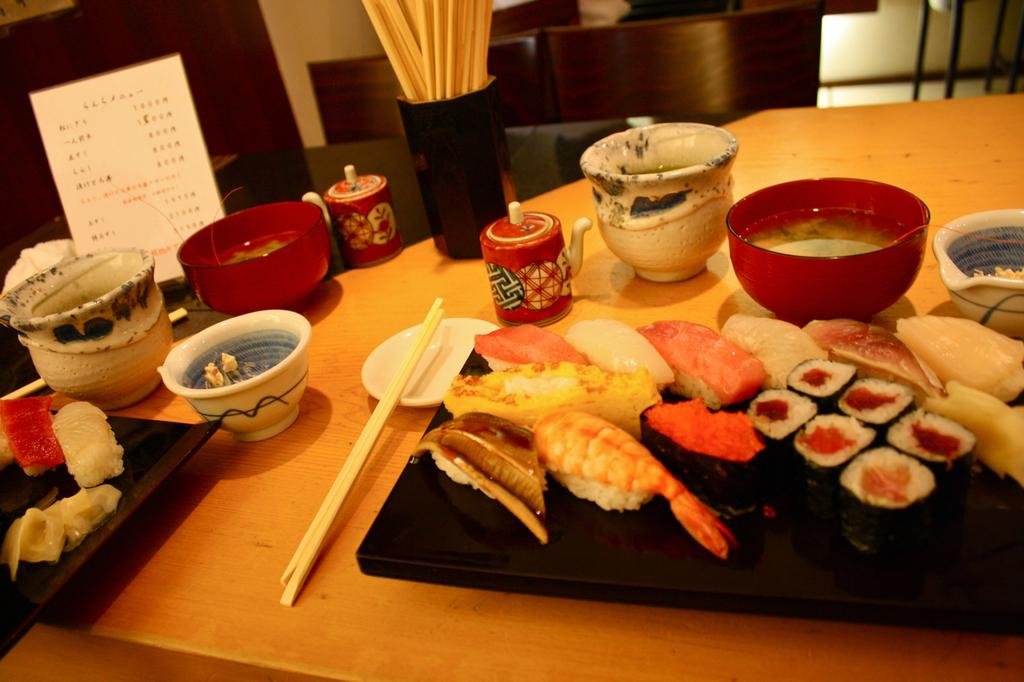What type of furniture is present in the image? There is a table in the image. What is placed on the table? There is a tray, a bowl, a teapot, and a plate on the table. What utensils are visible in the image? There are chopsticks in the image. What can be seen on the tray? There is food visible in the image. What is the purpose of the stand in the image? The stand is not explicitly described in the facts, so we cannot determine its purpose. What is written on the card in the image? The facts do not mention any text or message on the card, so we cannot determine its content. What type of seating is visible in the background of the image? There are chairs in the background of the image. What type of dirt can be seen on the table in the image? There is no dirt visible on the table in the image. What kind of yam is being served on the plate in the image? The facts do not mention any specific type of food, including yams, being served on the plate. 